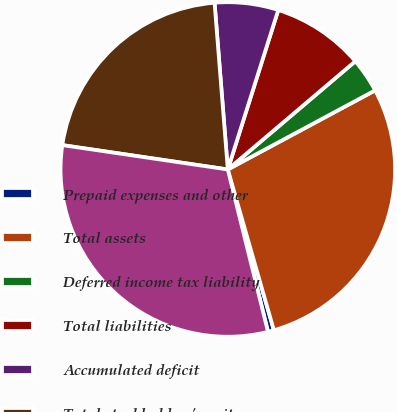<chart> <loc_0><loc_0><loc_500><loc_500><pie_chart><fcel>Prepaid expenses and other<fcel>Total assets<fcel>Deferred income tax liability<fcel>Total liabilities<fcel>Accumulated deficit<fcel>Total stockholders' equity<fcel>Total liabilities and equity<nl><fcel>0.58%<fcel>28.4%<fcel>3.36%<fcel>8.92%<fcel>6.14%<fcel>21.41%<fcel>31.19%<nl></chart> 